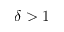Convert formula to latex. <formula><loc_0><loc_0><loc_500><loc_500>\delta > 1</formula> 